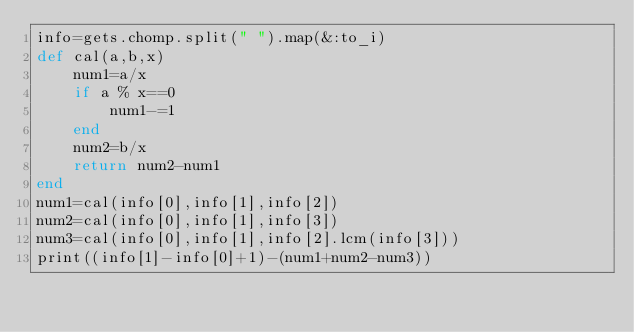Convert code to text. <code><loc_0><loc_0><loc_500><loc_500><_Ruby_>info=gets.chomp.split(" ").map(&:to_i)
def cal(a,b,x)
	num1=a/x
	if a % x==0
		num1-=1
	end
	num2=b/x
	return num2-num1
end
num1=cal(info[0],info[1],info[2])
num2=cal(info[0],info[1],info[3])
num3=cal(info[0],info[1],info[2].lcm(info[3]))
print((info[1]-info[0]+1)-(num1+num2-num3))</code> 